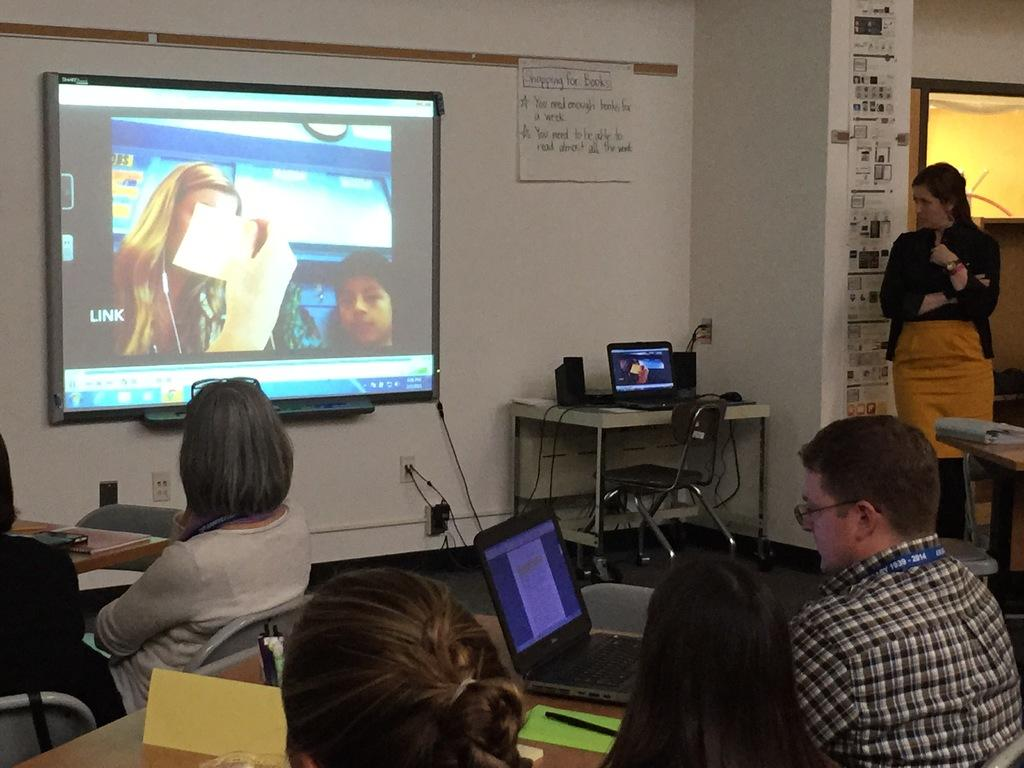What is the color of the wall in the image? The wall in the image is white. What is present on the wall in the image? There is a sheet on the wall in the image. What can be seen on the sheet in the image? There is a screen on the sheet in the image. What are the people in the image doing? The people in the image are sitting on chairs. What is on the table in the image? There is a laptop on the table in the image. What might the people be using the laptop for? The people might be using the laptop for work, browsing the internet, or other activities. Can you tell me how many times the people in the image smiled during the meeting? There is no indication of smiles or a meeting in the image, so it is not possible to answer that question. 